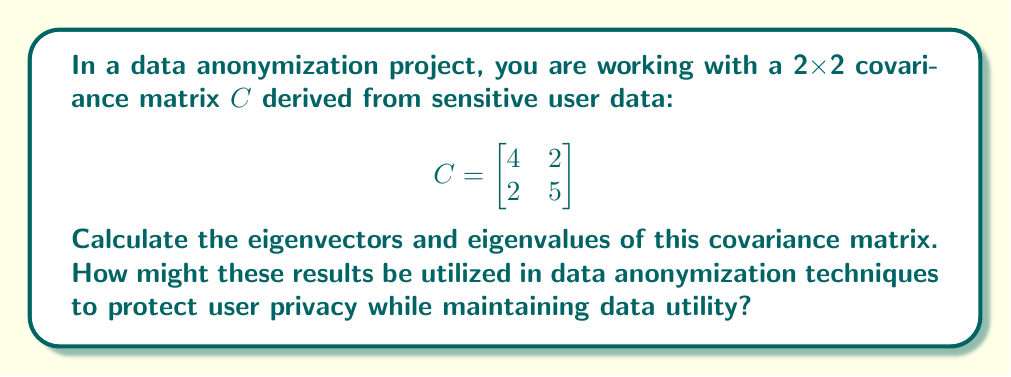Solve this math problem. To find the eigenvectors and eigenvalues of the covariance matrix $C$, we follow these steps:

1) First, we need to solve the characteristic equation:
   $det(C - \lambda I) = 0$

   $$\begin{vmatrix}
   4-\lambda & 2 \\
   2 & 5-\lambda
   \end{vmatrix} = 0$$

2) Expanding the determinant:
   $(4-\lambda)(5-\lambda) - 4 = 0$
   $\lambda^2 - 9\lambda + 16 = 0$

3) Solving this quadratic equation:
   $(\lambda - 6)(\lambda - 3) = 0$
   $\lambda_1 = 6$ and $\lambda_2 = 3$

4) Now, for each eigenvalue, we find the corresponding eigenvector by solving $(C - \lambda I)v = 0$:

   For $\lambda_1 = 6$:
   $$\begin{bmatrix}
   -2 & 2 \\
   2 & -1
   \end{bmatrix}\begin{bmatrix}
   v_1 \\
   v_2
   \end{bmatrix} = \begin{bmatrix}
   0 \\
   0
   \end{bmatrix}$$

   This gives us: $-2v_1 + 2v_2 = 0$, or $v_1 = v_2$
   We can choose $v_1 = \begin{bmatrix} 1 \\ 1 \end{bmatrix}$

   For $\lambda_2 = 3$:
   $$\begin{bmatrix}
   1 & 2 \\
   2 & 2
   \end{bmatrix}\begin{bmatrix}
   v_1 \\
   v_2
   \end{bmatrix} = \begin{bmatrix}
   0 \\
   0
   \end{bmatrix}$$

   This gives us: $v_1 + 2v_2 = 0$, or $v_1 = -2v_2$
   We can choose $v_2 = \begin{bmatrix} -2 \\ 1 \end{bmatrix}$

5) Normalizing these eigenvectors:
   $e_1 = \frac{1}{\sqrt{2}}\begin{bmatrix} 1 \\ 1 \end{bmatrix}$
   $e_2 = \frac{1}{\sqrt{5}}\begin{bmatrix} -2 \\ 1 \end{bmatrix}$

In data anonymization, these results can be used in several ways:

1. Principal Component Analysis (PCA): The eigenvectors represent the principal components of the data, with the larger eigenvalue (6) indicating the direction of greatest variance. This can be used to reduce dimensionality while preserving the most important features of the data.

2. Noise Addition: The eigenvalues represent the variance along each principal component. Adding noise proportional to these values can help preserve the overall structure of the data while masking individual data points.

3. Data Transformation: The eigenvectors can be used to rotate the data into a new coordinate system, which can be useful for applying other anonymization techniques or for creating synthetic data that maintains the same covariance structure.

4. k-anonymity and l-diversity: Understanding the principal components can guide the process of generalizing or suppressing certain attributes to achieve these privacy models while minimizing information loss.
Answer: Eigenvalues: $\lambda_1 = 6$, $\lambda_2 = 3$

Normalized eigenvectors:
$e_1 = \frac{1}{\sqrt{2}}\begin{bmatrix} 1 \\ 1 \end{bmatrix}$
$e_2 = \frac{1}{\sqrt{5}}\begin{bmatrix} -2 \\ 1 \end{bmatrix}$

These results can be used in data anonymization techniques such as PCA for dimensionality reduction, noise addition based on eigenvalues, data transformation using eigenvectors, and to guide the implementation of k-anonymity and l-diversity models. 